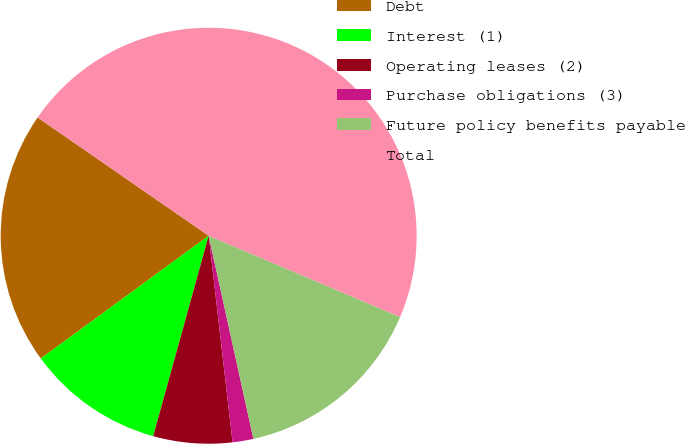Convert chart to OTSL. <chart><loc_0><loc_0><loc_500><loc_500><pie_chart><fcel>Debt<fcel>Interest (1)<fcel>Operating leases (2)<fcel>Purchase obligations (3)<fcel>Future policy benefits payable<fcel>Total<nl><fcel>19.68%<fcel>10.65%<fcel>6.13%<fcel>1.62%<fcel>15.16%<fcel>46.76%<nl></chart> 